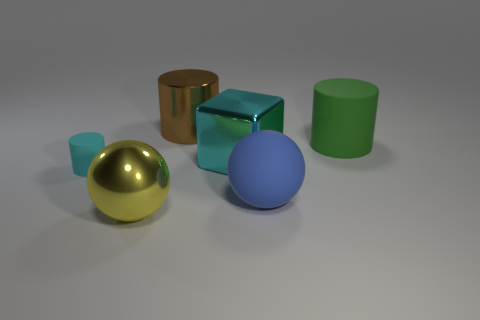Add 1 large yellow shiny spheres. How many objects exist? 7 Subtract all blocks. How many objects are left? 5 Add 2 brown shiny things. How many brown shiny things are left? 3 Add 3 purple balls. How many purple balls exist? 3 Subtract 0 yellow cylinders. How many objects are left? 6 Subtract all large purple things. Subtract all big yellow spheres. How many objects are left? 5 